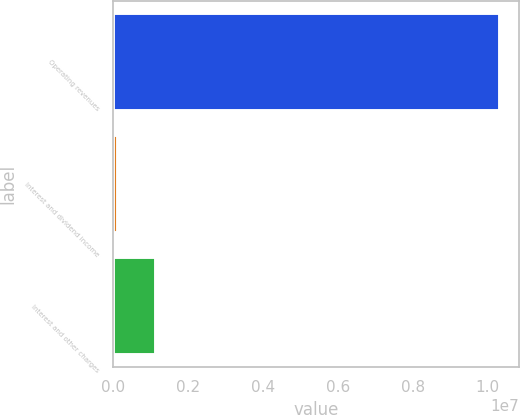<chart> <loc_0><loc_0><loc_500><loc_500><bar_chart><fcel>Operating revenues<fcel>Interest and dividend income<fcel>Interest and other charges<nl><fcel>1.03186e+07<fcel>122657<fcel>1.14225e+06<nl></chart> 